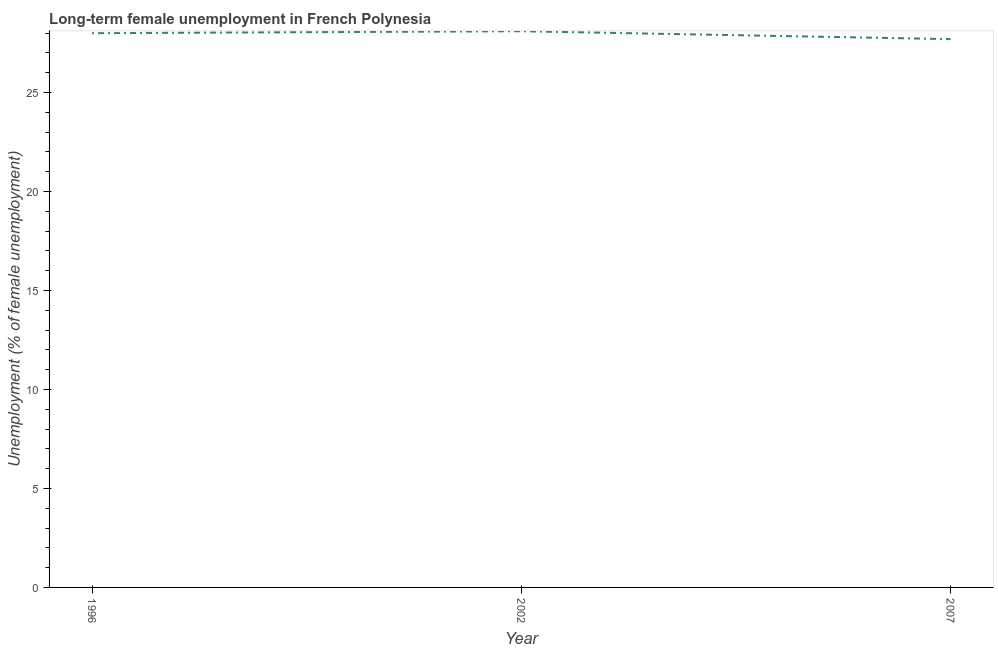What is the long-term female unemployment in 1996?
Provide a succinct answer. 28. Across all years, what is the maximum long-term female unemployment?
Your answer should be compact. 28.1. Across all years, what is the minimum long-term female unemployment?
Give a very brief answer. 27.7. What is the sum of the long-term female unemployment?
Provide a short and direct response. 83.8. What is the difference between the long-term female unemployment in 2002 and 2007?
Your answer should be compact. 0.4. What is the average long-term female unemployment per year?
Provide a short and direct response. 27.93. Do a majority of the years between 1996 and 2002 (inclusive) have long-term female unemployment greater than 27 %?
Keep it short and to the point. Yes. What is the ratio of the long-term female unemployment in 1996 to that in 2002?
Make the answer very short. 1. Is the long-term female unemployment in 2002 less than that in 2007?
Keep it short and to the point. No. Is the difference between the long-term female unemployment in 1996 and 2002 greater than the difference between any two years?
Keep it short and to the point. No. What is the difference between the highest and the second highest long-term female unemployment?
Provide a short and direct response. 0.1. What is the difference between the highest and the lowest long-term female unemployment?
Your answer should be compact. 0.4. Does the long-term female unemployment monotonically increase over the years?
Keep it short and to the point. No. What is the difference between two consecutive major ticks on the Y-axis?
Make the answer very short. 5. Does the graph contain grids?
Make the answer very short. No. What is the title of the graph?
Your answer should be compact. Long-term female unemployment in French Polynesia. What is the label or title of the X-axis?
Your response must be concise. Year. What is the label or title of the Y-axis?
Offer a terse response. Unemployment (% of female unemployment). What is the Unemployment (% of female unemployment) in 1996?
Provide a short and direct response. 28. What is the Unemployment (% of female unemployment) of 2002?
Provide a short and direct response. 28.1. What is the Unemployment (% of female unemployment) in 2007?
Make the answer very short. 27.7. What is the difference between the Unemployment (% of female unemployment) in 2002 and 2007?
Your answer should be compact. 0.4. What is the ratio of the Unemployment (% of female unemployment) in 1996 to that in 2002?
Offer a terse response. 1. 